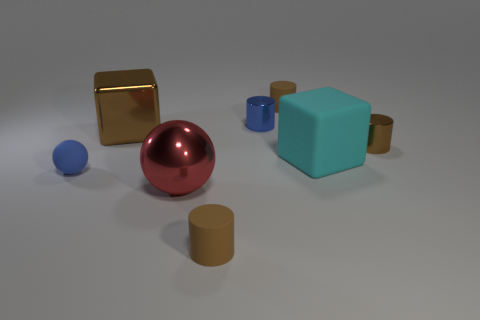There is a matte thing that is the same size as the brown metallic cube; what is its color?
Make the answer very short. Cyan. What number of things are in front of the tiny brown metallic thing and to the left of the large red ball?
Your answer should be compact. 1. What material is the cyan cube?
Make the answer very short. Rubber. How many things are either small red rubber cylinders or large matte objects?
Ensure brevity in your answer.  1. There is a brown rubber cylinder in front of the tiny rubber sphere; is it the same size as the brown rubber cylinder behind the rubber sphere?
Make the answer very short. Yes. How many other things are there of the same size as the blue metal cylinder?
Give a very brief answer. 4. How many objects are either things that are behind the small brown metal cylinder or things behind the blue ball?
Your answer should be very brief. 5. Is the large red thing made of the same material as the small brown cylinder in front of the big rubber cube?
Provide a succinct answer. No. What number of other objects are the same shape as the tiny brown shiny object?
Your response must be concise. 3. The cylinder that is in front of the blue object to the left of the tiny brown matte object in front of the big brown block is made of what material?
Provide a succinct answer. Rubber. 